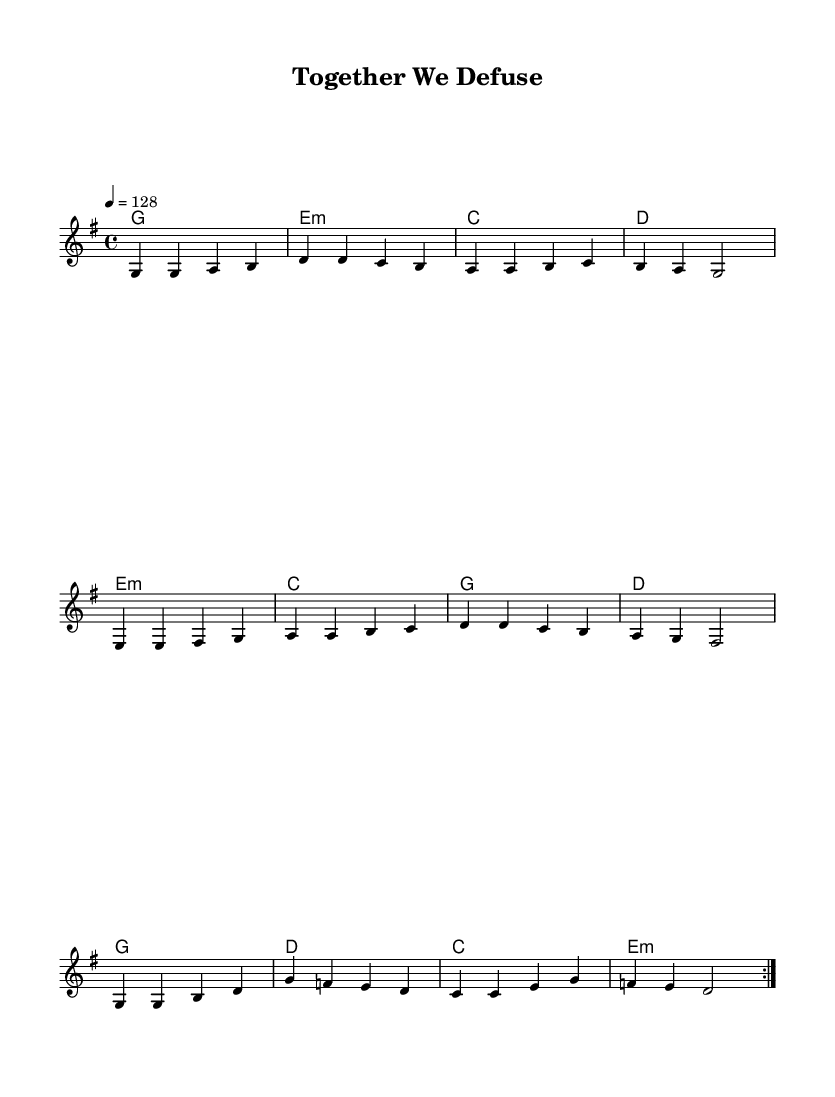What is the key signature of this music? The key signature is G major, which has one sharp (F#). This can be observed in the score where it indicates the key at the beginning.
Answer: G major What is the time signature of the music? The time signature is 4/4, which means there are four beats in each measure, indicated at the start of the score.
Answer: 4/4 What is the tempo marking for this piece? The tempo is marked as 4 equals 128, indicating a quarter note should be played at a speed of 128 beats per minute. This is specified in the tempo indication at the beginning of the score.
Answer: 128 How many measures are in the verse? The verse consists of four measures, which can be counted directly from the melodic section of the score where the phrase is clearly defined.
Answer: 4 What is the structure of the song? The structure consists of Verse, Pre-Chorus, and Chorus, as indicated by the sections in the melody. Each section is repeated twice, which is common in K-Pop song structure to emphasize key themes.
Answer: Verse, Pre-Chorus, Chorus What is the first chord of the chorus? The first chord of the chorus is G major, which is located in the harmonies section. A G major chord is represented in the first position of the chorus.
Answer: G What theme is prominent in this K-Pop track? The theme of teamwork and cooperation is prominent, as indicated by the song title "Together We Defuse," suggesting a collaborative effort, which is a common theme found in K-Pop tracks focusing on unity.
Answer: Teamwork 